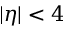<formula> <loc_0><loc_0><loc_500><loc_500>| \eta | < 4</formula> 